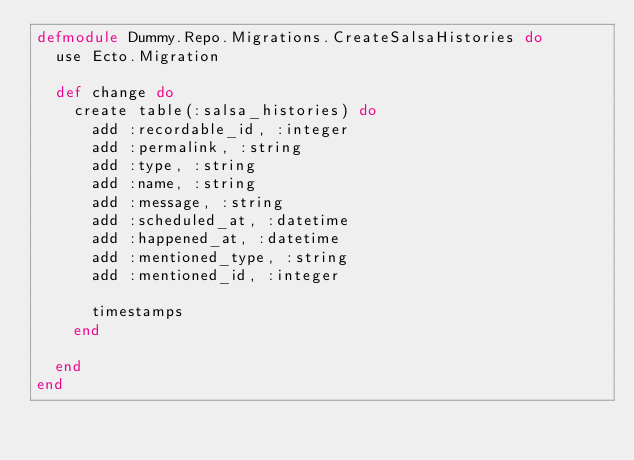<code> <loc_0><loc_0><loc_500><loc_500><_Elixir_>defmodule Dummy.Repo.Migrations.CreateSalsaHistories do
  use Ecto.Migration

  def change do
    create table(:salsa_histories) do
      add :recordable_id, :integer
      add :permalink, :string
      add :type, :string
      add :name, :string
      add :message, :string
      add :scheduled_at, :datetime
      add :happened_at, :datetime
      add :mentioned_type, :string
      add :mentioned_id, :integer

      timestamps
    end

  end
end</code> 